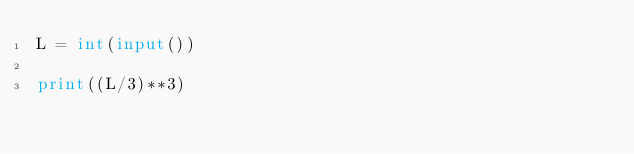<code> <loc_0><loc_0><loc_500><loc_500><_Python_>L = int(input())
    
print((L/3)**3)
    </code> 